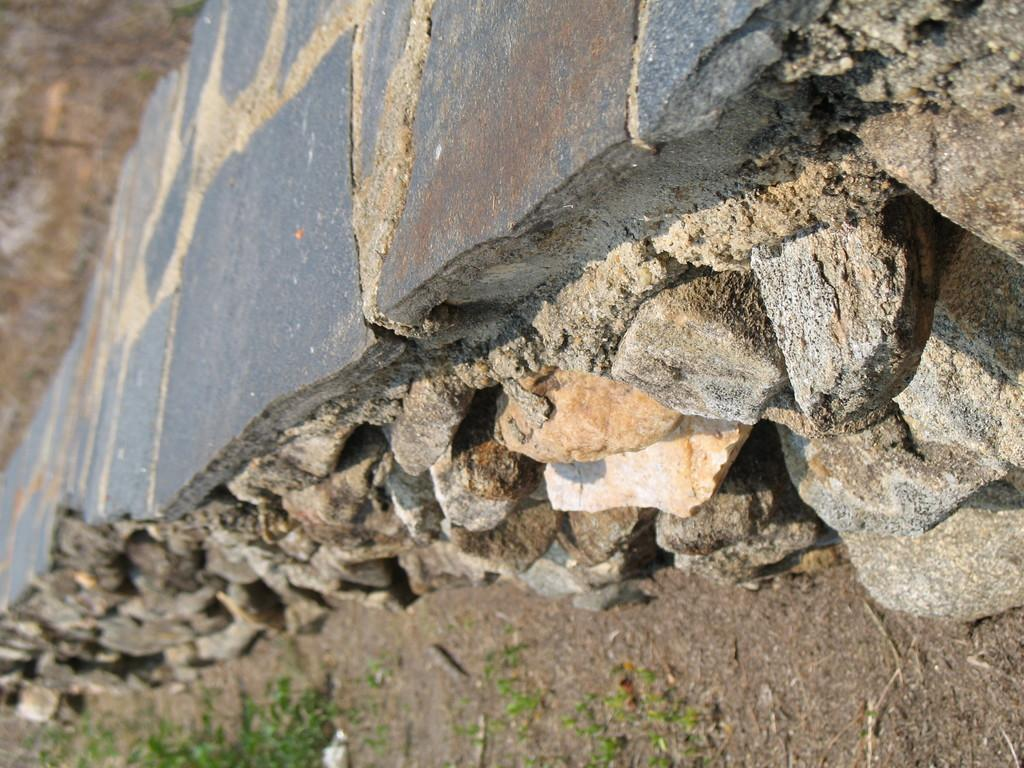What is located in the foreground of the image? There is a wall and rocks in the foreground of the image. What type of vegetation can be seen at the bottom of the image? There is grass and sand at the bottom of the image. How many sisters are playing with the bubble in the image? There is no bubble or sisters present in the image. 